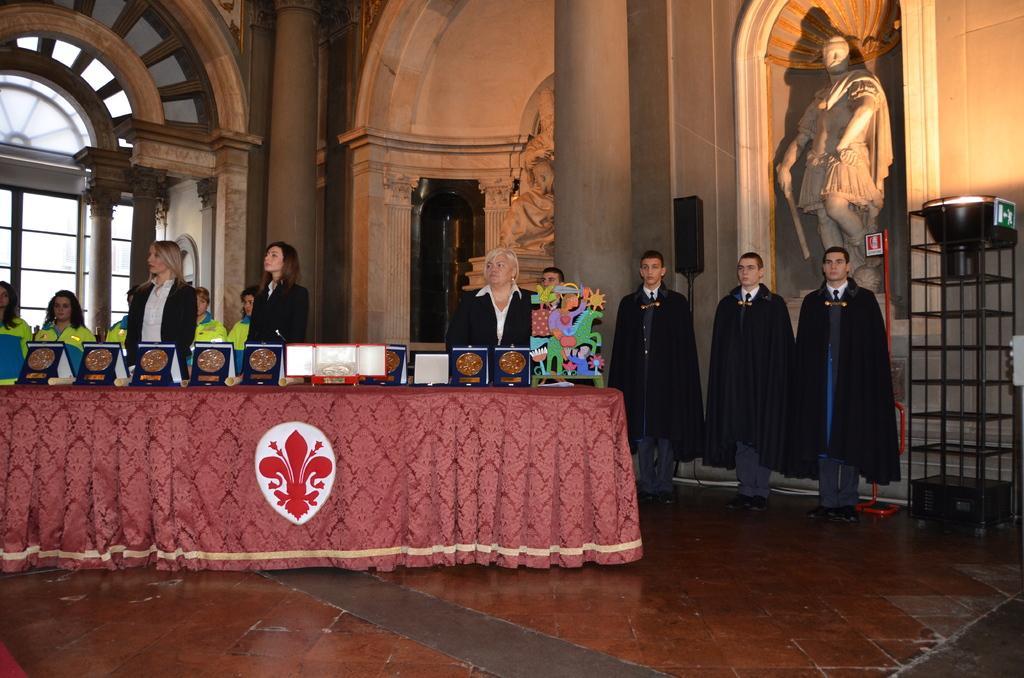How would you summarize this image in a sentence or two? In this image we can see people standing on the floor and a table is placed in front of them. On the table we can see tablecloth, mementos and a decor. In the background there are statues, windows, pillars and an electric light. 